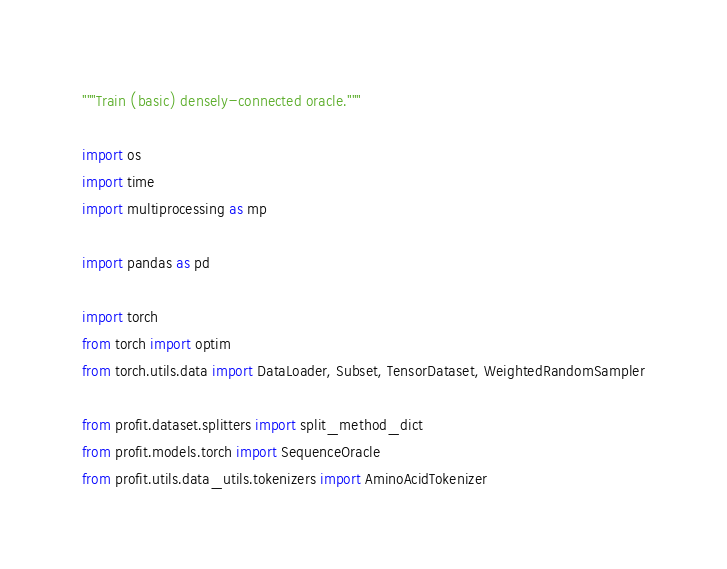Convert code to text. <code><loc_0><loc_0><loc_500><loc_500><_Python_>"""Train (basic) densely-connected oracle."""

import os
import time
import multiprocessing as mp

import pandas as pd

import torch
from torch import optim
from torch.utils.data import DataLoader, Subset, TensorDataset, WeightedRandomSampler

from profit.dataset.splitters import split_method_dict
from profit.models.torch import SequenceOracle
from profit.utils.data_utils.tokenizers import AminoAcidTokenizer</code> 